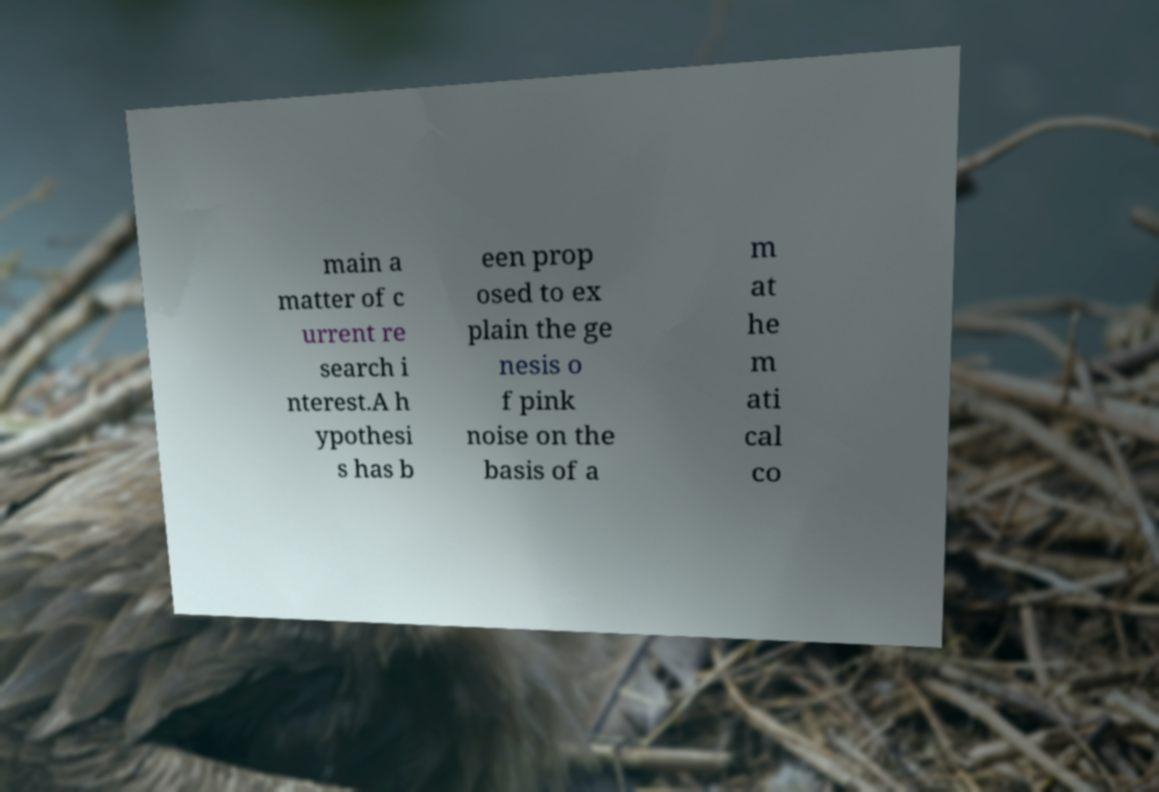Can you speculate on what might be the mathematical concept mentioned in the text about pink noise? While the full text isn't completely clear, the mention of 'basis of a mathematical co' likely refers to a mathematical concept or theory integral to understanding the behavior of pink noise. This could include stochastic differential equations or statistical models that try to characterize how and why pink noise occurs in natural systems. 